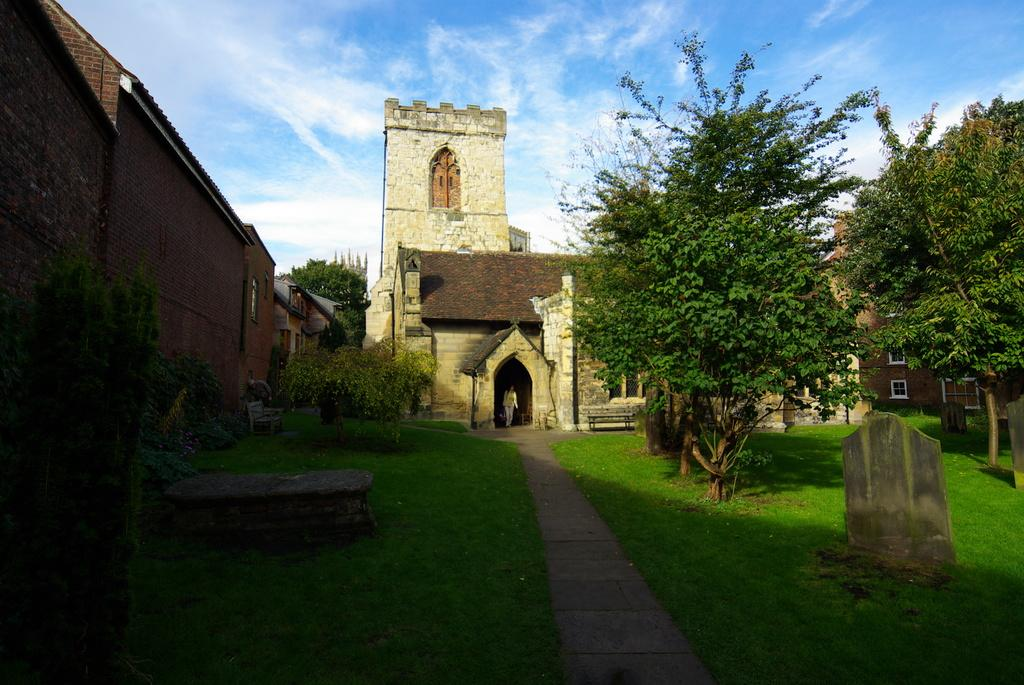What type of structures can be seen in the image? There are buildings in the image. What natural elements are present in the image? There are trees and plants in the image. Can you describe the person in the image? There is a person in the image. What is the ground surface like in the image? The ground with grass is visible in the image. What type of seating is available in the image? There are benches in the image. What is the purpose of the graves in the image? The graves in the image are for burial and memorial purposes. What is visible in the sky in the image? The sky is visible in the image, and clouds are present. What advice is the person in the image giving to the trees? There is no indication in the image that the person is giving advice to the trees. How does the person in the image wash the clouds in the sky? There is no person in the image washing the clouds; the clouds are a natural atmospheric phenomenon. What type of mask is the person in the image wearing? There is no person in the image wearing a mask; the person is not depicted with any facial covering. 